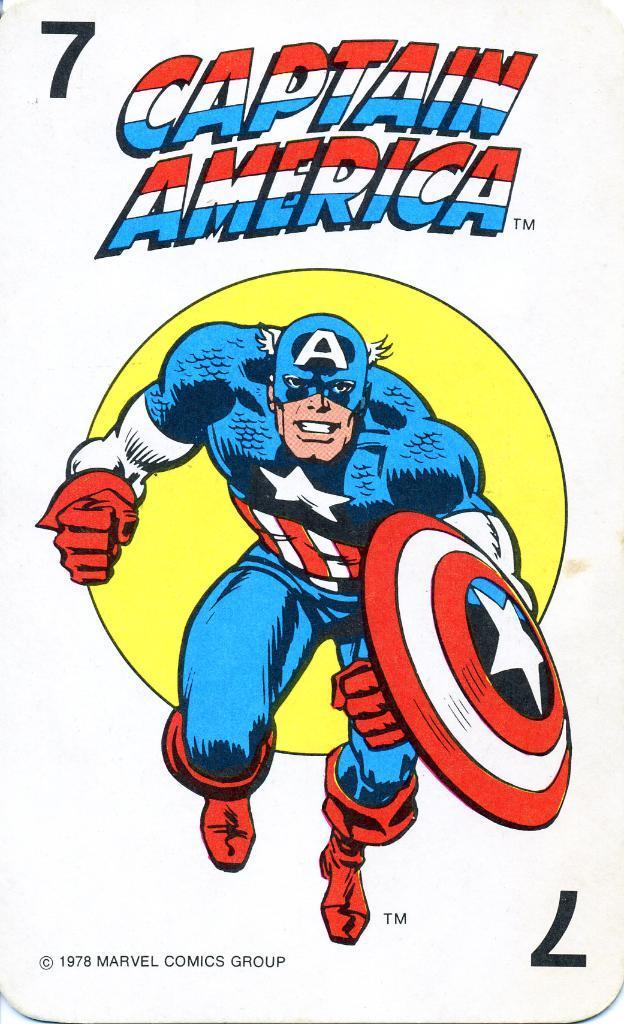In one or two sentences, can you explain what this image depicts? In this image, we can see a picture, on that picture we can see a man and CAPTAIN AMERICA is printed on the picture. 